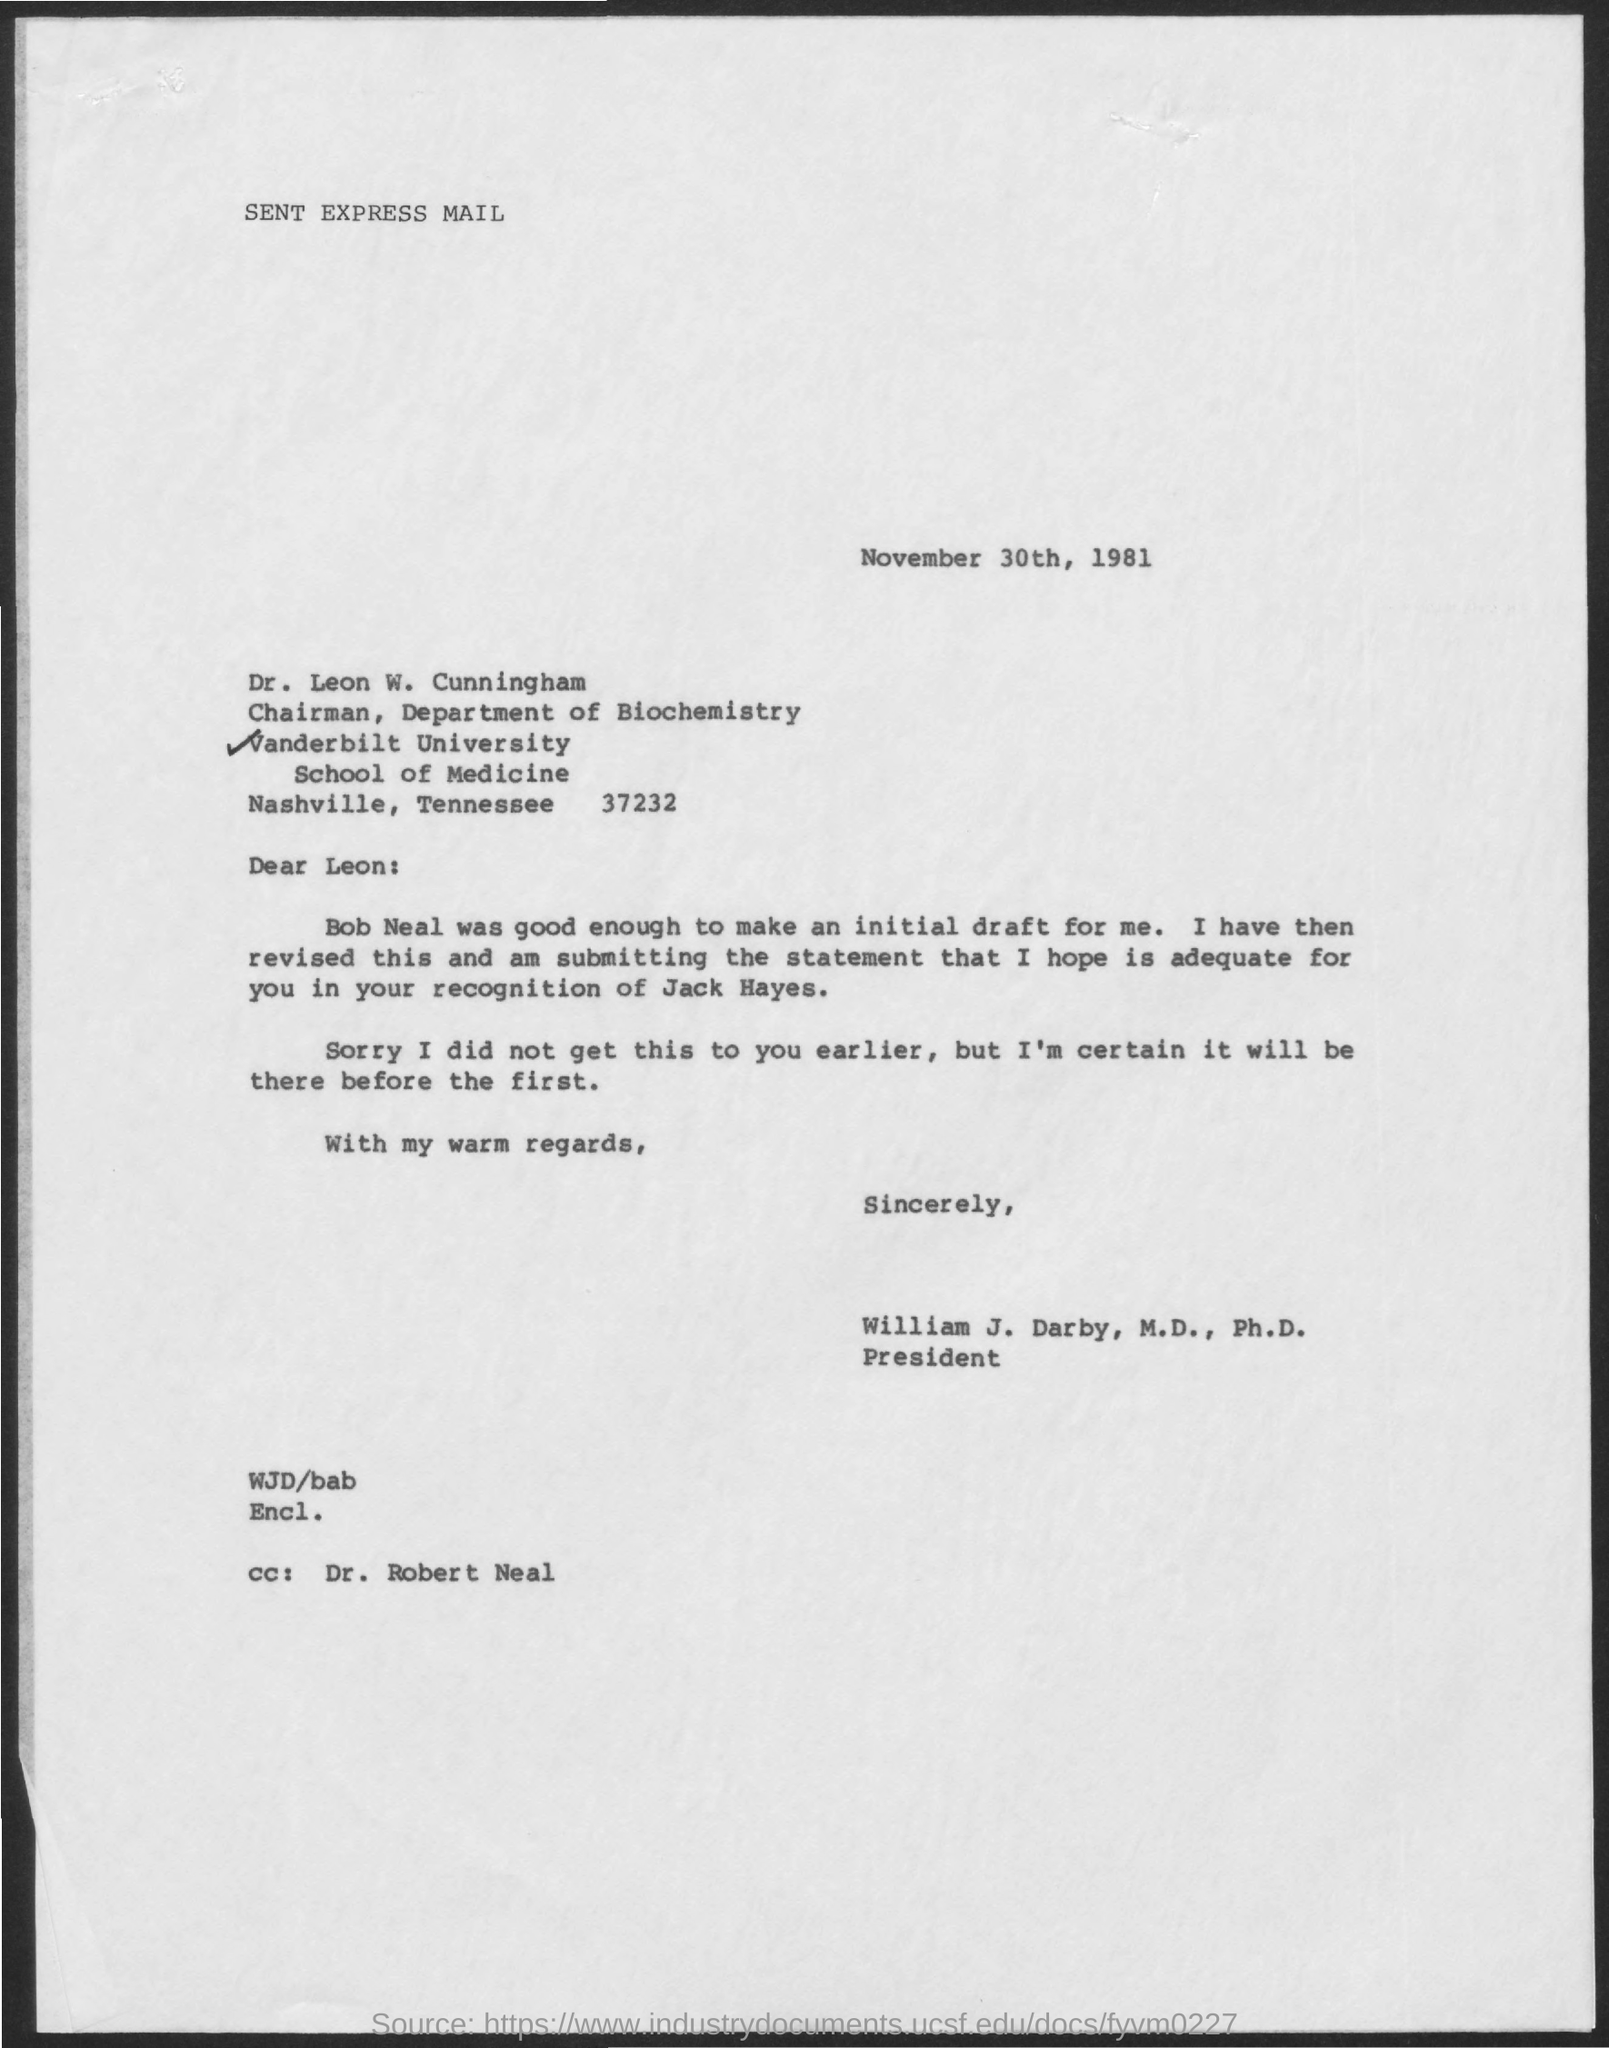Draw attention to some important aspects in this diagram. The date on the document is November 30th, 1981. The letter is addressed to Dr. Leon W. Cunningham. The initial draft was made by Bob Neal, who was considered to be good enough. 